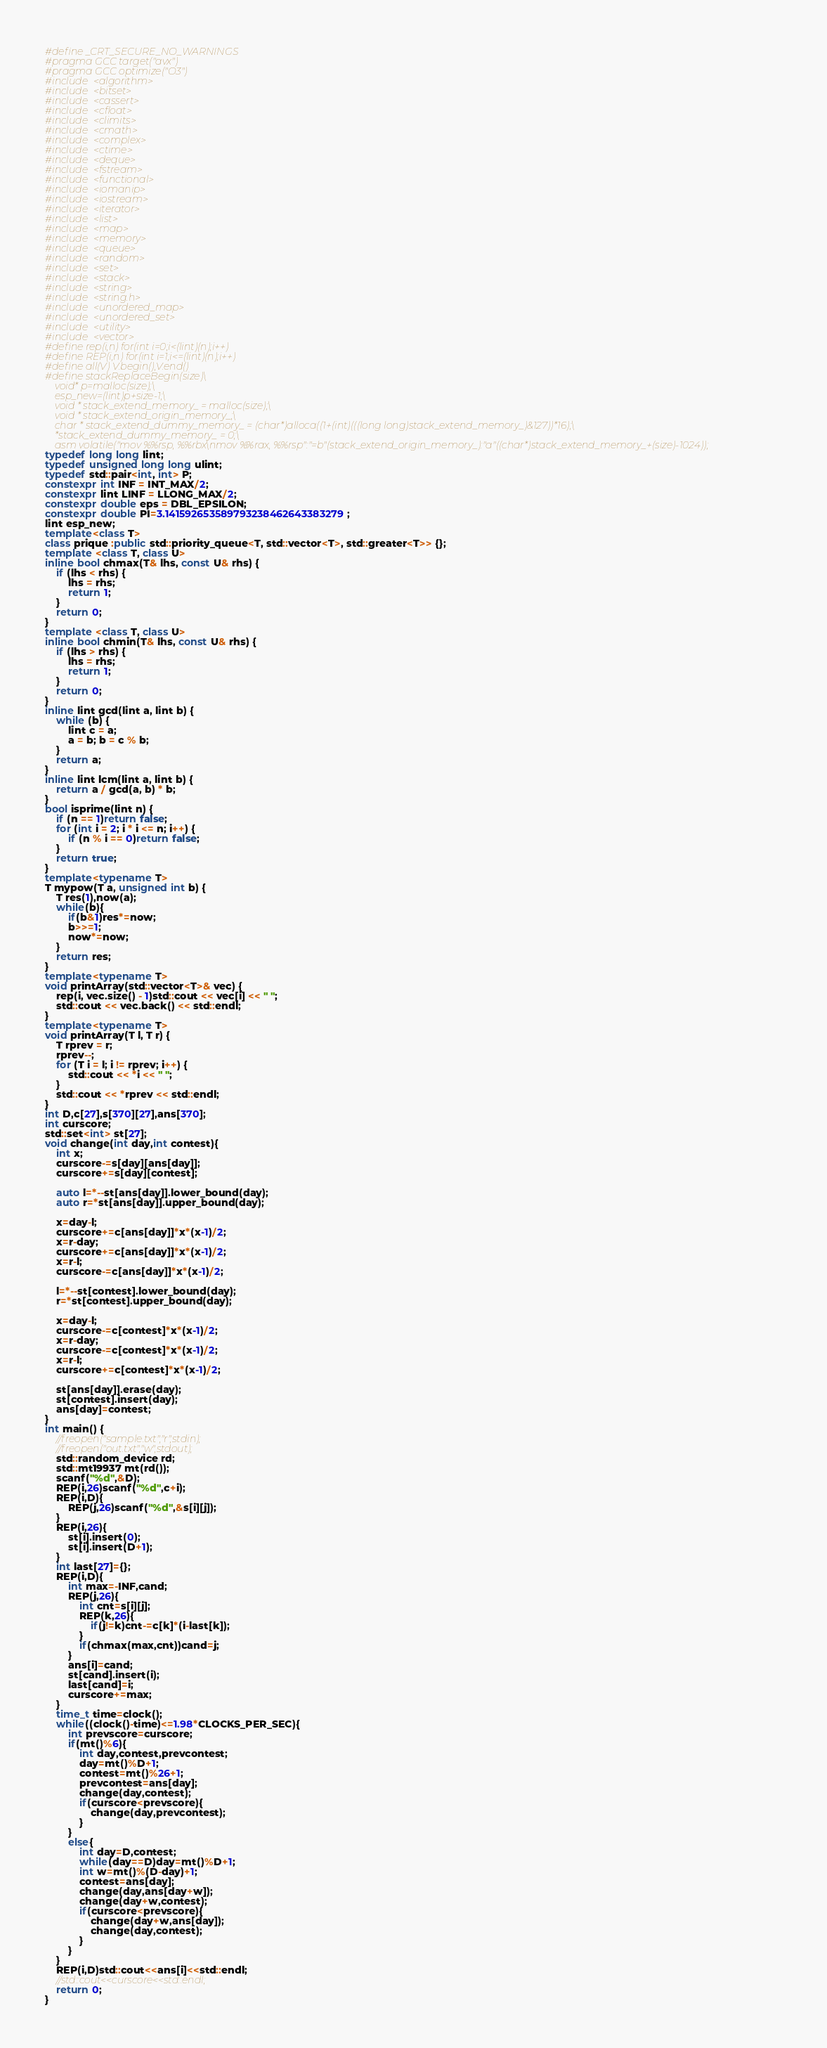Convert code to text. <code><loc_0><loc_0><loc_500><loc_500><_C++_>#define _CRT_SECURE_NO_WARNINGS
#pragma GCC target("avx")
#pragma GCC optimize("O3")
#include <algorithm>
#include <bitset>
#include <cassert>
#include <cfloat>
#include <climits>
#include <cmath>
#include <complex>
#include <ctime>
#include <deque>
#include <fstream>
#include <functional>
#include <iomanip>
#include <iostream>
#include <iterator>
#include <list>
#include <map>
#include <memory>
#include <queue>
#include <random>
#include <set>
#include <stack>
#include <string>
#include <string.h>
#include <unordered_map>
#include <unordered_set>
#include <utility>
#include <vector>
#define rep(i,n) for(int i=0;i<(lint)(n);i++)
#define REP(i,n) for(int i=1;i<=(lint)(n);i++)
#define all(V) V.begin(),V.end()
#define stackReplaceBegin(size)\
	void* p=malloc(size);\
	esp_new=(lint)p+size-1;\
	void * stack_extend_memory_ = malloc(size);\
	void * stack_extend_origin_memory_;\
	char * stack_extend_dummy_memory_ = (char*)alloca((1+(int)(((long long)stack_extend_memory_)&127))*16);\
	*stack_extend_dummy_memory_ = 0;\
	asm volatile("mov %%rsp, %%rbx\nmov %%rax, %%rsp":"=b"(stack_extend_origin_memory_):"a"((char*)stack_extend_memory_+(size)-1024));
typedef long long lint;
typedef unsigned long long ulint;
typedef std::pair<int, int> P;
constexpr int INF = INT_MAX/2;
constexpr lint LINF = LLONG_MAX/2;
constexpr double eps = DBL_EPSILON;
constexpr double PI=3.141592653589793238462643383279;
lint esp_new;
template<class T>
class prique :public std::priority_queue<T, std::vector<T>, std::greater<T>> {};
template <class T, class U>
inline bool chmax(T& lhs, const U& rhs) {
	if (lhs < rhs) {
		lhs = rhs;
		return 1;
	}
	return 0;
}
template <class T, class U>
inline bool chmin(T& lhs, const U& rhs) {
	if (lhs > rhs) {
		lhs = rhs;
		return 1;
	}
	return 0;
}
inline lint gcd(lint a, lint b) {
	while (b) {
		lint c = a;
		a = b; b = c % b;
	}
	return a;
}
inline lint lcm(lint a, lint b) {
	return a / gcd(a, b) * b;
}
bool isprime(lint n) {
	if (n == 1)return false;
	for (int i = 2; i * i <= n; i++) {
		if (n % i == 0)return false;
	}
	return true;
}
template<typename T>
T mypow(T a, unsigned int b) {
	T res(1),now(a);
	while(b){
		if(b&1)res*=now;
		b>>=1;
		now*=now;
	}
	return res;
}
template<typename T>
void printArray(std::vector<T>& vec) {
	rep(i, vec.size() - 1)std::cout << vec[i] << " ";
	std::cout << vec.back() << std::endl;
}
template<typename T>
void printArray(T l, T r) {
	T rprev = r;
	rprev--;
	for (T i = l; i != rprev; i++) {
		std::cout << *i << " ";
	}
	std::cout << *rprev << std::endl;
}
int D,c[27],s[370][27],ans[370];
int curscore;
std::set<int> st[27];
void change(int day,int contest){
	int x;
	curscore-=s[day][ans[day]];
	curscore+=s[day][contest];

	auto l=*--st[ans[day]].lower_bound(day);
	auto r=*st[ans[day]].upper_bound(day);

	x=day-l;
	curscore+=c[ans[day]]*x*(x-1)/2;
	x=r-day;
	curscore+=c[ans[day]]*x*(x-1)/2;
	x=r-l;
	curscore-=c[ans[day]]*x*(x-1)/2;

	l=*--st[contest].lower_bound(day);
	r=*st[contest].upper_bound(day);

	x=day-l;
	curscore-=c[contest]*x*(x-1)/2;
	x=r-day;
	curscore-=c[contest]*x*(x-1)/2;
	x=r-l;
	curscore+=c[contest]*x*(x-1)/2;

	st[ans[day]].erase(day);
	st[contest].insert(day);
	ans[day]=contest;
}
int main() {
	//freopen("sample.txt","r",stdin);
	//freopen("out.txt","w",stdout);
	std::random_device rd;
	std::mt19937 mt(rd());
	scanf("%d",&D);
	REP(i,26)scanf("%d",c+i);
	REP(i,D){
		REP(j,26)scanf("%d",&s[i][j]);
	}
	REP(i,26){
		st[i].insert(0);
		st[i].insert(D+1);
	}
	int last[27]={};
	REP(i,D){
		int max=-INF,cand;
		REP(j,26){
			int cnt=s[i][j];
			REP(k,26){
				if(j!=k)cnt-=c[k]*(i-last[k]);
			}
			if(chmax(max,cnt))cand=j;
		}
		ans[i]=cand;
		st[cand].insert(i);
		last[cand]=i;
		curscore+=max;
	}
	time_t time=clock();
	while((clock()-time)<=1.98*CLOCKS_PER_SEC){
		int prevscore=curscore;
		if(mt()%6){
			int day,contest,prevcontest;
			day=mt()%D+1;
			contest=mt()%26+1;
			prevcontest=ans[day];
			change(day,contest);
			if(curscore<prevscore){
				change(day,prevcontest);
			}
		}
		else{
			int day=D,contest;
			while(day==D)day=mt()%D+1;
			int w=mt()%(D-day)+1;
			contest=ans[day];
			change(day,ans[day+w]);
			change(day+w,contest);
			if(curscore<prevscore){
				change(day+w,ans[day]);
				change(day,contest);
			}
		}
	}
	REP(i,D)std::cout<<ans[i]<<std::endl;
	//std::cout<<curscore<<std::endl;
	return 0;
}</code> 